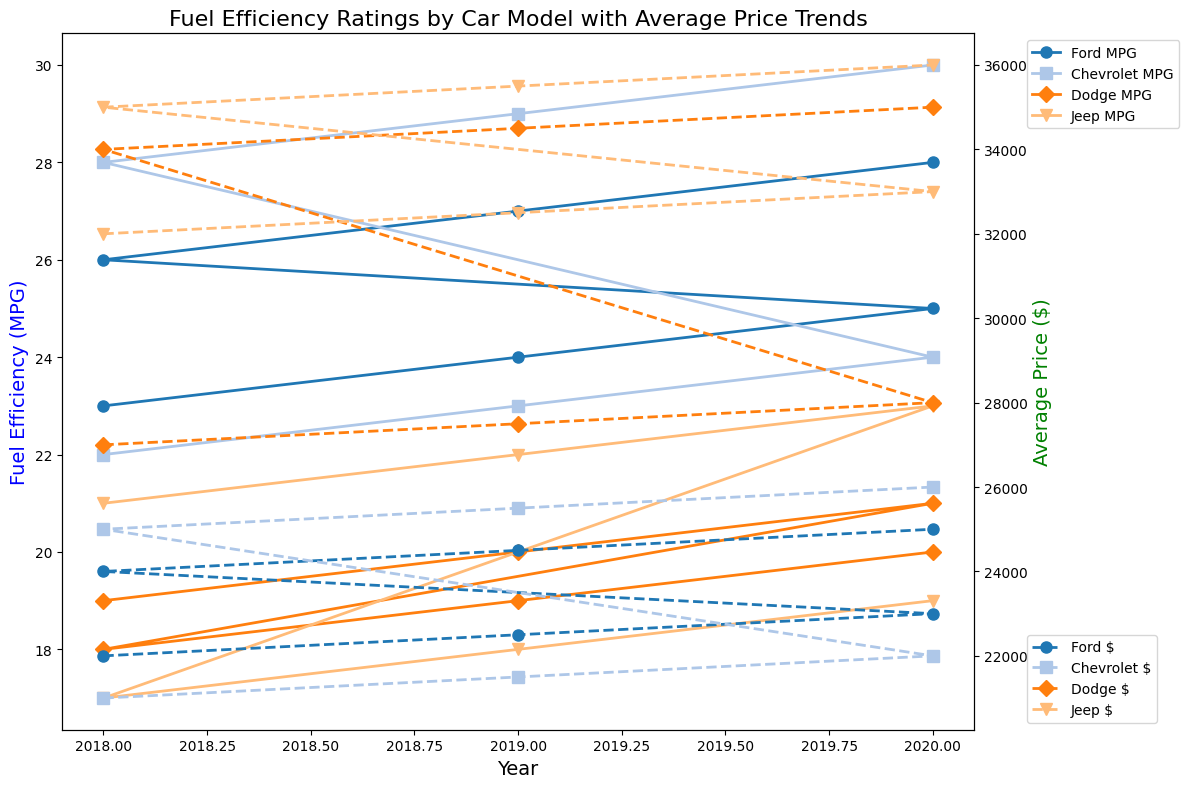What are the overall trends in fuel efficiency and average price for Ford cars from 2018 to 2020? To understand the trends, look at the plot lines for Ford's car models: Fusion and Escape. Both their fuel efficiencies (solid lines) and average prices (dashed lines) increase over the years 2018 to 2020.
Answer: Both fuel efficiency and average price trends are increasing How does the fuel efficiency of the Jeep Wrangler in 2020 compare with the Dodge Charger in the same year? To compare, look at the solid line markers for Jeep Wrangler and Dodge Charger in the year 2020. The Jeep Wrangler's fuel efficiency is 19 MPG, while the Dodge Charger's is 21 MPG, indicating the Dodge Charger is more fuel efficient.
Answer: Dodge Charger is more fuel efficient Which car model from Dodge has the lowest fuel efficiency across all years? Look at the fuel efficiency (solid lines) for Dodge's models: Charger and Durango. Notice that Durango has a lower fuel efficiency (18, 19, 20 MPG) compared to Charger (19, 20, 21 MPG). The Dodge Durango maintains the lowest values.
Answer: Dodge Durango What is the average fuel efficiency for Chevrolet's cars in 2020? Identify the solid lines for Chevrolet's models (Malibu, Equinox) in the year 2020. Their fuel efficiencies are 24 MPG and 30 MPG, respectively. The average is (24 + 30) / 2 = 27 MPG.
Answer: 27 MPG Which car brand shows the largest increase in average price from 2018 to 2020? Determine the dashed lines representing average prices. Calculate the price increase for each brand: Ford (23000 - 22000 = 1000, 25000 - 24000 = 1000), Chevrolet (26000 - 21000 = 5000, 26000 - 25000 = 1000), Dodge (35000 - 34000 = 1000, 28000 - 27000 = 1000), and Jeep (36000 - 35000 = 1000, 33000 - 32000 = 1000). The largest increase belongs to Chevrolet Malibu (5000).
Answer: Chevrolet What is the difference in fuel efficiency between the most fuel-efficient and least fuel-efficient cars in 2020? Look at the solid lines for 2020 and find the highest and lowest fuel efficiencies: Jeep Wrangler (19 MPG) and Chevrolet Equinox (30 MPG). The difference is 30 - 19 = 11 MPG.
Answer: 11 MPG For which car model did the average price increase the most consistently each year from 2018 to 2020? Check the dashed lines to see the year-over-year price increases for each model. Ford Escape (increased consistently by 500 each year: 24000, 24500, 25000); other models either show less consistent increases or larger intervals between each year.
Answer: Ford Escape How does the fuel efficiency of Jeep Grand Cherokee in 2018 compare with 2020? Compare solid line markers for Jeep Grand Cherokee in 2018 and 2020. The fuel efficiencies are 21 MPG in 2018 and 23 MPG in 2020.
Answer: 23 MPG higher than 21 MPG Which brand has the most variation in fuel efficiency across its models in 2020? Look at the spread of solid lines for each brand in 2020. Dodge has the most variation with Charger at 21 MPG and Durango at 20 MPG, a variation of 1 MPG. Other brands have closer ranges.
Answer: Dodge How does the average price trend for the Ford Fusion compare to the Chevrolet Malibu from 2018 to 2020? Compare the dashed lines for Ford Fusion and Chevrolet Malibu between 2018 and 2020. Both show a steady increase, but the Malibu consistently has lower prices than the Fusion.
Answer: Malibu consistently lower than Fusion 